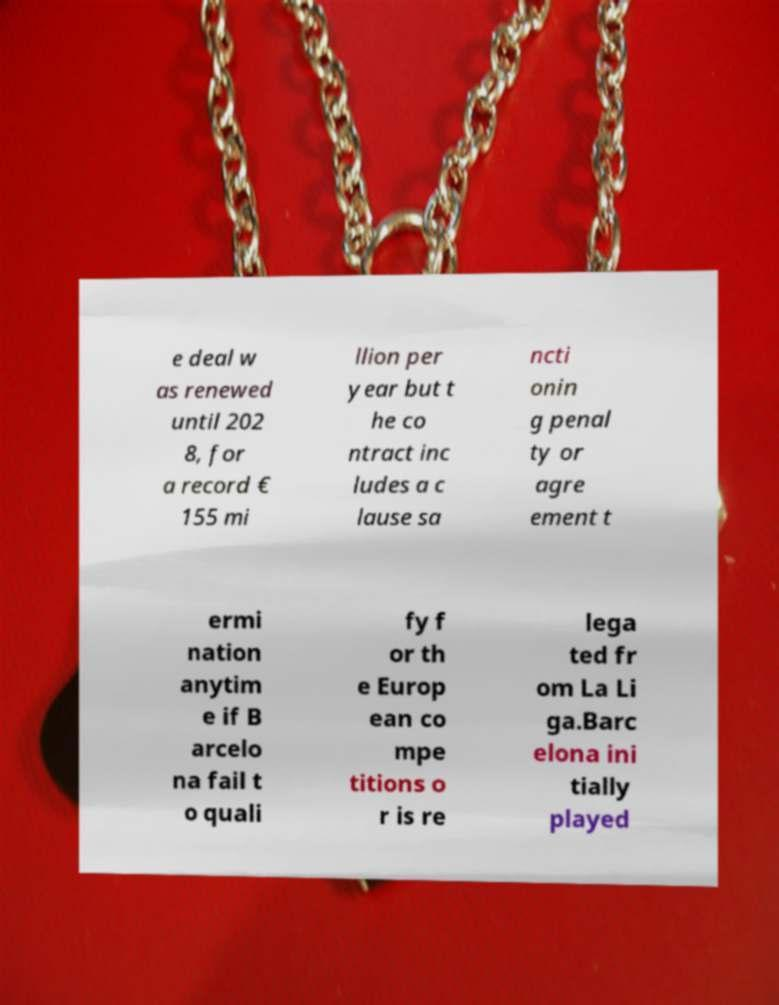For documentation purposes, I need the text within this image transcribed. Could you provide that? e deal w as renewed until 202 8, for a record € 155 mi llion per year but t he co ntract inc ludes a c lause sa ncti onin g penal ty or agre ement t ermi nation anytim e if B arcelo na fail t o quali fy f or th e Europ ean co mpe titions o r is re lega ted fr om La Li ga.Barc elona ini tially played 